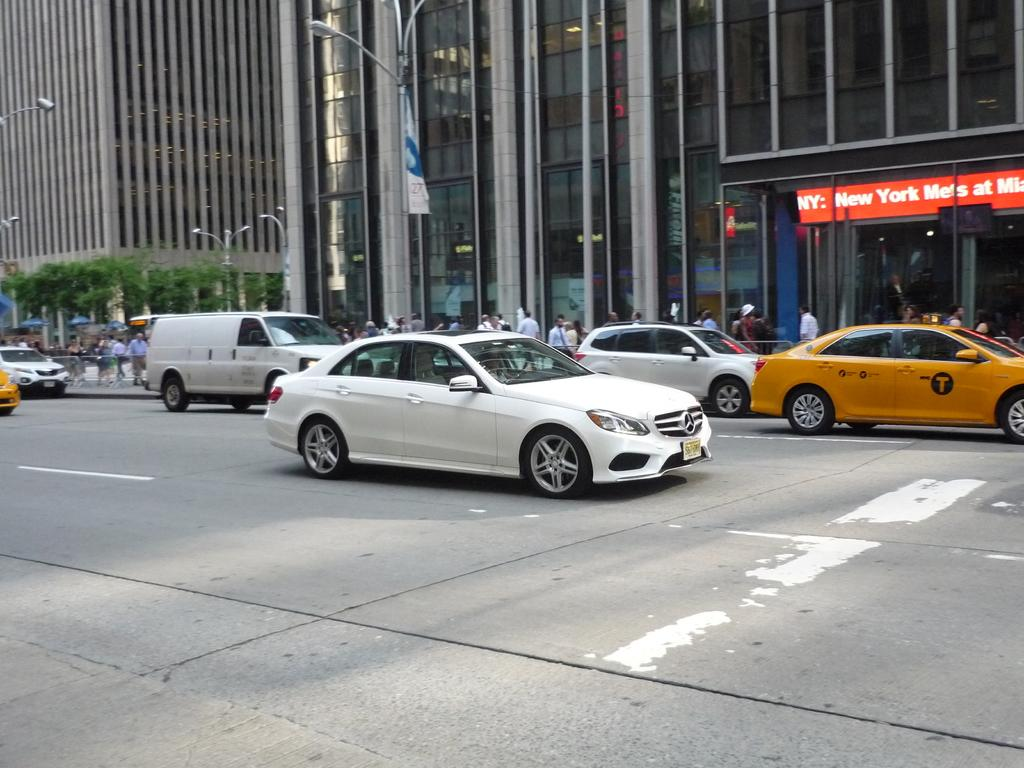<image>
Relay a brief, clear account of the picture shown. Yellow taxi on a street in front of a building that says New York. 